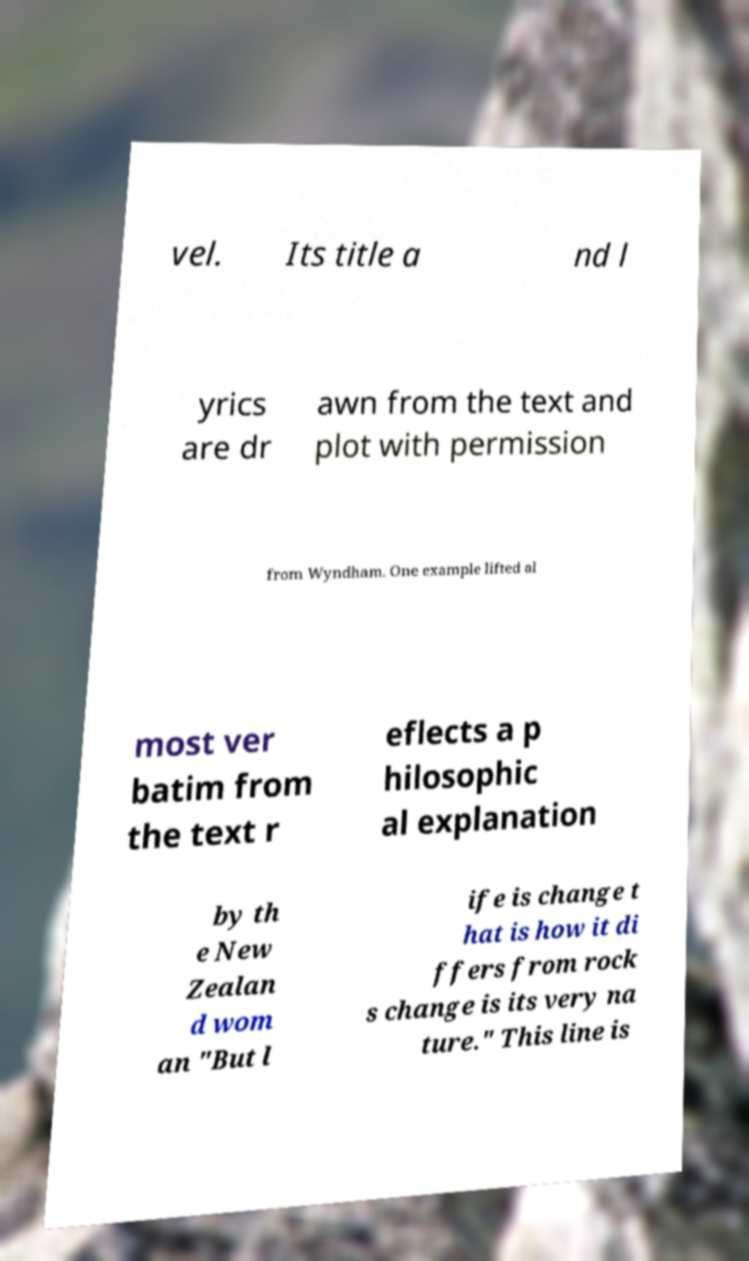What messages or text are displayed in this image? I need them in a readable, typed format. vel. Its title a nd l yrics are dr awn from the text and plot with permission from Wyndham. One example lifted al most ver batim from the text r eflects a p hilosophic al explanation by th e New Zealan d wom an "But l ife is change t hat is how it di ffers from rock s change is its very na ture." This line is 